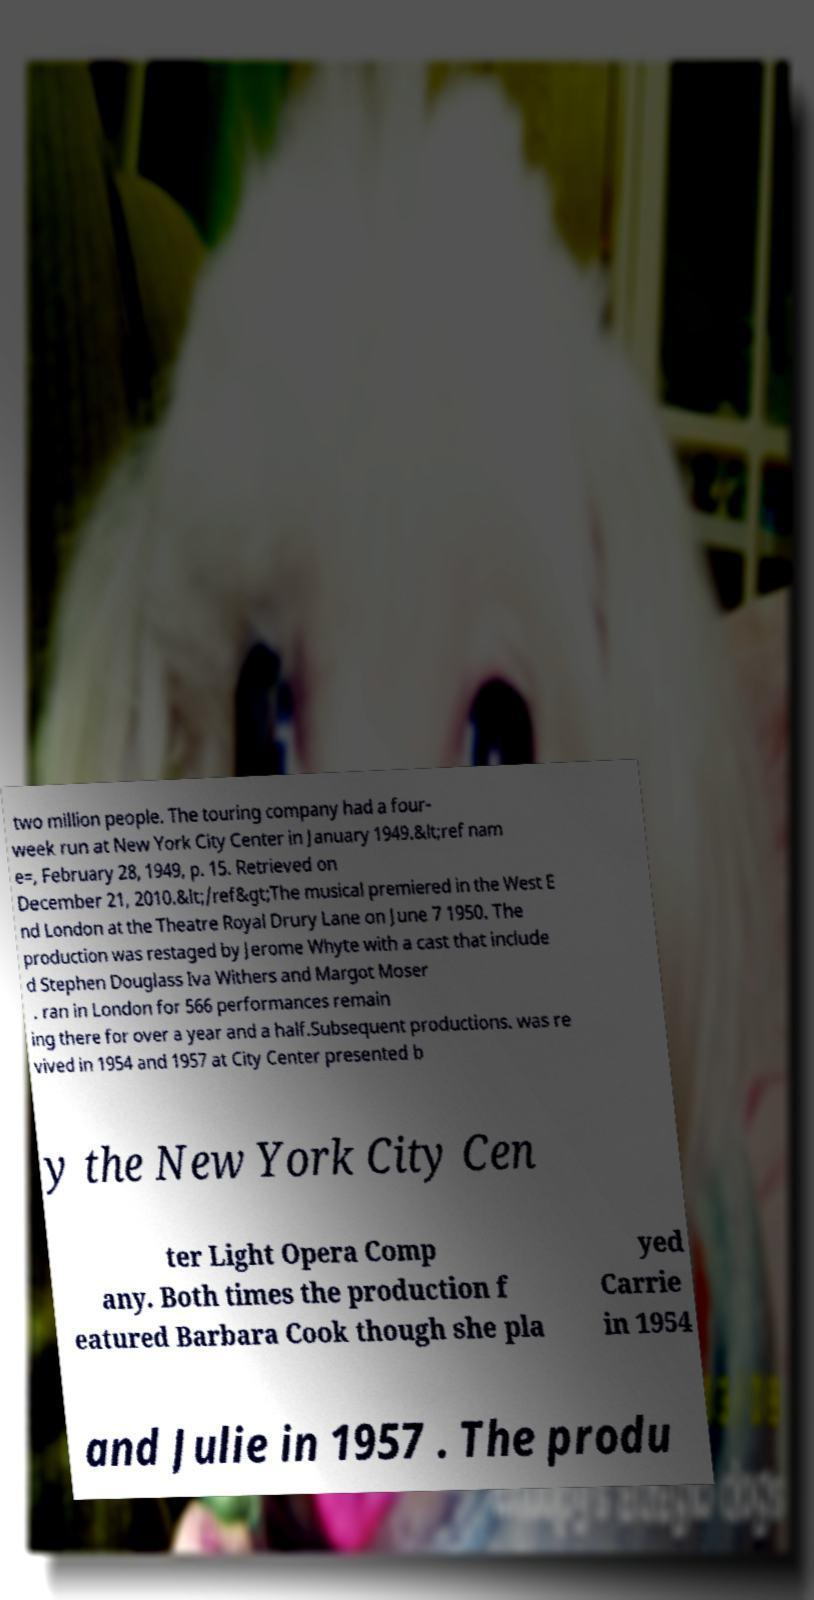I need the written content from this picture converted into text. Can you do that? two million people. The touring company had a four- week run at New York City Center in January 1949.&lt;ref nam e=, February 28, 1949, p. 15. Retrieved on December 21, 2010.&lt;/ref&gt;The musical premiered in the West E nd London at the Theatre Royal Drury Lane on June 7 1950. The production was restaged by Jerome Whyte with a cast that include d Stephen Douglass Iva Withers and Margot Moser . ran in London for 566 performances remain ing there for over a year and a half.Subsequent productions. was re vived in 1954 and 1957 at City Center presented b y the New York City Cen ter Light Opera Comp any. Both times the production f eatured Barbara Cook though she pla yed Carrie in 1954 and Julie in 1957 . The produ 